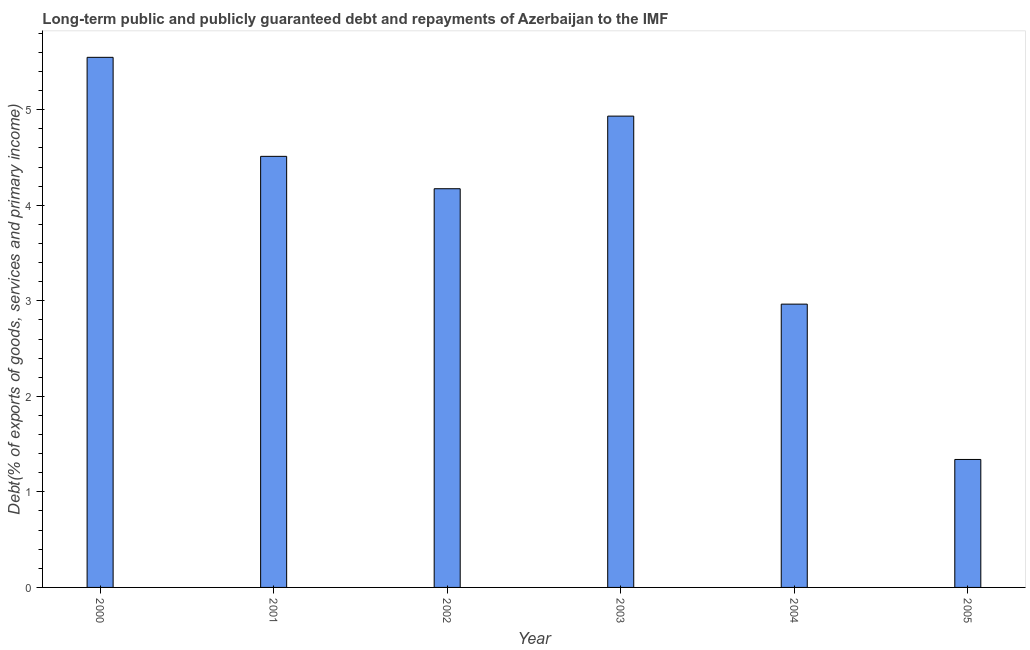Does the graph contain any zero values?
Give a very brief answer. No. Does the graph contain grids?
Offer a terse response. No. What is the title of the graph?
Offer a terse response. Long-term public and publicly guaranteed debt and repayments of Azerbaijan to the IMF. What is the label or title of the X-axis?
Your answer should be very brief. Year. What is the label or title of the Y-axis?
Give a very brief answer. Debt(% of exports of goods, services and primary income). What is the debt service in 2001?
Ensure brevity in your answer.  4.51. Across all years, what is the maximum debt service?
Keep it short and to the point. 5.55. Across all years, what is the minimum debt service?
Provide a short and direct response. 1.34. In which year was the debt service maximum?
Make the answer very short. 2000. What is the sum of the debt service?
Keep it short and to the point. 23.47. What is the difference between the debt service in 2000 and 2004?
Make the answer very short. 2.58. What is the average debt service per year?
Provide a succinct answer. 3.91. What is the median debt service?
Your answer should be compact. 4.34. What is the ratio of the debt service in 2001 to that in 2005?
Provide a succinct answer. 3.37. Is the debt service in 2002 less than that in 2005?
Your answer should be very brief. No. What is the difference between the highest and the second highest debt service?
Your answer should be very brief. 0.61. Is the sum of the debt service in 2002 and 2004 greater than the maximum debt service across all years?
Ensure brevity in your answer.  Yes. What is the difference between the highest and the lowest debt service?
Offer a very short reply. 4.21. How many bars are there?
Your answer should be compact. 6. Are all the bars in the graph horizontal?
Make the answer very short. No. Are the values on the major ticks of Y-axis written in scientific E-notation?
Offer a very short reply. No. What is the Debt(% of exports of goods, services and primary income) in 2000?
Provide a short and direct response. 5.55. What is the Debt(% of exports of goods, services and primary income) of 2001?
Your response must be concise. 4.51. What is the Debt(% of exports of goods, services and primary income) in 2002?
Your answer should be compact. 4.17. What is the Debt(% of exports of goods, services and primary income) of 2003?
Offer a very short reply. 4.93. What is the Debt(% of exports of goods, services and primary income) of 2004?
Ensure brevity in your answer.  2.97. What is the Debt(% of exports of goods, services and primary income) in 2005?
Offer a very short reply. 1.34. What is the difference between the Debt(% of exports of goods, services and primary income) in 2000 and 2001?
Make the answer very short. 1.04. What is the difference between the Debt(% of exports of goods, services and primary income) in 2000 and 2002?
Your answer should be compact. 1.38. What is the difference between the Debt(% of exports of goods, services and primary income) in 2000 and 2003?
Your answer should be compact. 0.62. What is the difference between the Debt(% of exports of goods, services and primary income) in 2000 and 2004?
Your answer should be compact. 2.58. What is the difference between the Debt(% of exports of goods, services and primary income) in 2000 and 2005?
Your answer should be compact. 4.21. What is the difference between the Debt(% of exports of goods, services and primary income) in 2001 and 2002?
Ensure brevity in your answer.  0.34. What is the difference between the Debt(% of exports of goods, services and primary income) in 2001 and 2003?
Keep it short and to the point. -0.42. What is the difference between the Debt(% of exports of goods, services and primary income) in 2001 and 2004?
Keep it short and to the point. 1.55. What is the difference between the Debt(% of exports of goods, services and primary income) in 2001 and 2005?
Your answer should be compact. 3.17. What is the difference between the Debt(% of exports of goods, services and primary income) in 2002 and 2003?
Make the answer very short. -0.76. What is the difference between the Debt(% of exports of goods, services and primary income) in 2002 and 2004?
Give a very brief answer. 1.21. What is the difference between the Debt(% of exports of goods, services and primary income) in 2002 and 2005?
Your answer should be very brief. 2.83. What is the difference between the Debt(% of exports of goods, services and primary income) in 2003 and 2004?
Make the answer very short. 1.97. What is the difference between the Debt(% of exports of goods, services and primary income) in 2003 and 2005?
Your answer should be very brief. 3.59. What is the difference between the Debt(% of exports of goods, services and primary income) in 2004 and 2005?
Offer a very short reply. 1.63. What is the ratio of the Debt(% of exports of goods, services and primary income) in 2000 to that in 2001?
Provide a succinct answer. 1.23. What is the ratio of the Debt(% of exports of goods, services and primary income) in 2000 to that in 2002?
Offer a terse response. 1.33. What is the ratio of the Debt(% of exports of goods, services and primary income) in 2000 to that in 2004?
Your answer should be very brief. 1.87. What is the ratio of the Debt(% of exports of goods, services and primary income) in 2000 to that in 2005?
Make the answer very short. 4.14. What is the ratio of the Debt(% of exports of goods, services and primary income) in 2001 to that in 2002?
Ensure brevity in your answer.  1.08. What is the ratio of the Debt(% of exports of goods, services and primary income) in 2001 to that in 2003?
Provide a succinct answer. 0.92. What is the ratio of the Debt(% of exports of goods, services and primary income) in 2001 to that in 2004?
Offer a very short reply. 1.52. What is the ratio of the Debt(% of exports of goods, services and primary income) in 2001 to that in 2005?
Offer a terse response. 3.37. What is the ratio of the Debt(% of exports of goods, services and primary income) in 2002 to that in 2003?
Your response must be concise. 0.85. What is the ratio of the Debt(% of exports of goods, services and primary income) in 2002 to that in 2004?
Make the answer very short. 1.41. What is the ratio of the Debt(% of exports of goods, services and primary income) in 2002 to that in 2005?
Provide a succinct answer. 3.12. What is the ratio of the Debt(% of exports of goods, services and primary income) in 2003 to that in 2004?
Keep it short and to the point. 1.66. What is the ratio of the Debt(% of exports of goods, services and primary income) in 2003 to that in 2005?
Make the answer very short. 3.68. What is the ratio of the Debt(% of exports of goods, services and primary income) in 2004 to that in 2005?
Keep it short and to the point. 2.21. 